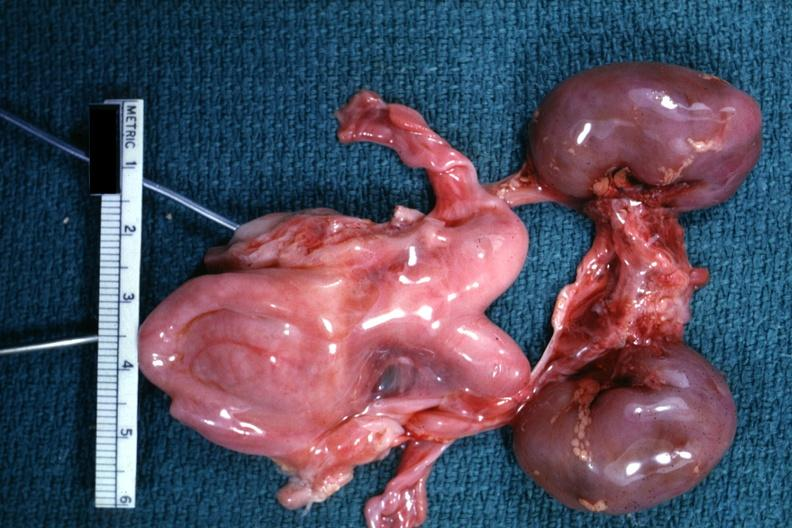what is present?
Answer the question using a single word or phrase. Bicornate uterus 